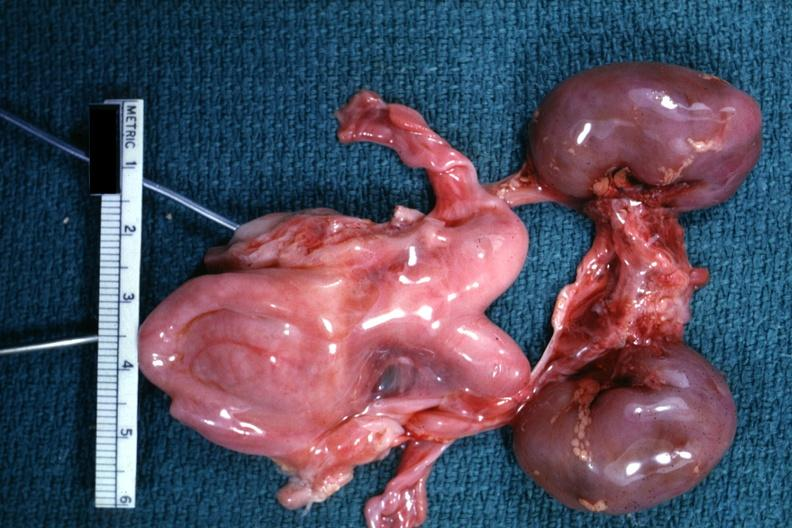what is present?
Answer the question using a single word or phrase. Bicornate uterus 